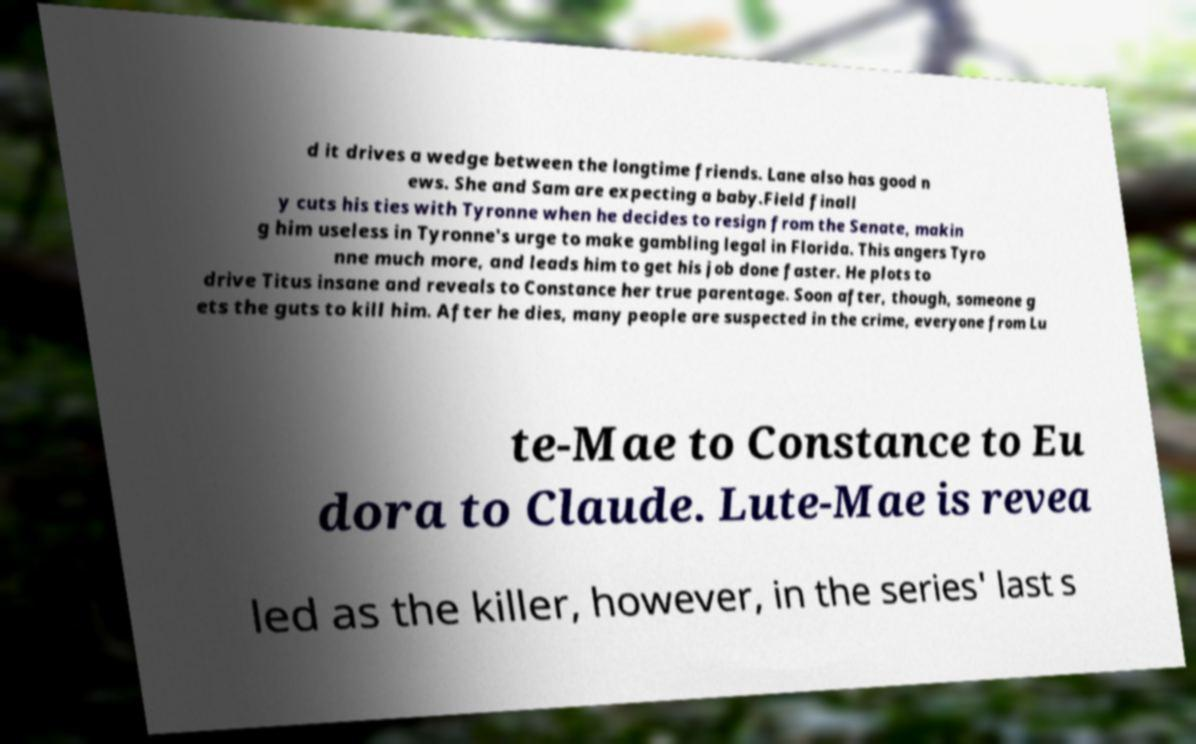Please identify and transcribe the text found in this image. d it drives a wedge between the longtime friends. Lane also has good n ews. She and Sam are expecting a baby.Field finall y cuts his ties with Tyronne when he decides to resign from the Senate, makin g him useless in Tyronne's urge to make gambling legal in Florida. This angers Tyro nne much more, and leads him to get his job done faster. He plots to drive Titus insane and reveals to Constance her true parentage. Soon after, though, someone g ets the guts to kill him. After he dies, many people are suspected in the crime, everyone from Lu te-Mae to Constance to Eu dora to Claude. Lute-Mae is revea led as the killer, however, in the series' last s 